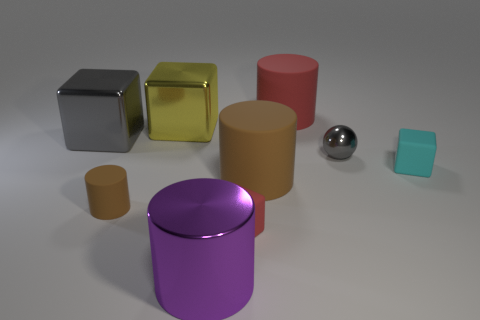Subtract all purple spheres. How many brown cylinders are left? 2 Subtract 1 cubes. How many cubes are left? 3 Subtract all big gray metallic cubes. How many cubes are left? 3 Subtract all red cubes. How many cubes are left? 3 Subtract 0 green cubes. How many objects are left? 9 Subtract all blocks. How many objects are left? 5 Subtract all cyan cubes. Subtract all purple spheres. How many cubes are left? 3 Subtract all large blue shiny cylinders. Subtract all big rubber objects. How many objects are left? 7 Add 3 large cubes. How many large cubes are left? 5 Add 2 big blue shiny cubes. How many big blue shiny cubes exist? 2 